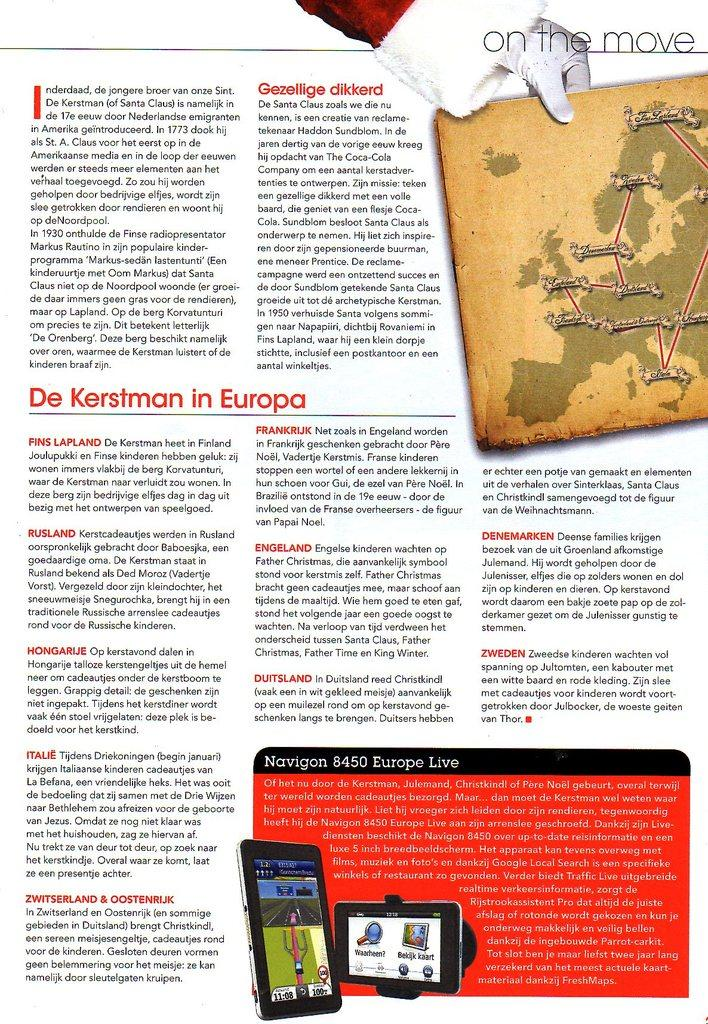<image>
Create a compact narrative representing the image presented. a paper that says on the move in the top right 